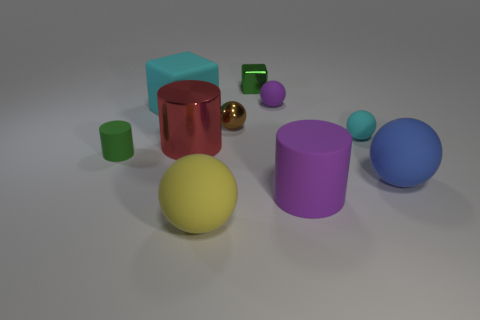Subtract all blue balls. How many balls are left? 4 Subtract all cyan balls. How many balls are left? 4 Subtract 2 spheres. How many spheres are left? 3 Subtract all red spheres. Subtract all blue blocks. How many spheres are left? 5 Subtract all cylinders. How many objects are left? 7 Add 5 tiny yellow metal balls. How many tiny yellow metal balls exist? 5 Subtract 0 red cubes. How many objects are left? 10 Subtract all big yellow matte things. Subtract all metallic balls. How many objects are left? 8 Add 9 big purple cylinders. How many big purple cylinders are left? 10 